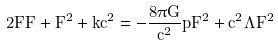Convert formula to latex. <formula><loc_0><loc_0><loc_500><loc_500>2 F \ddot { F } + { \dot { F } } ^ { 2 } + k c ^ { 2 } = - \frac { 8 \pi G } { c ^ { 2 } } p F ^ { 2 } + c ^ { 2 } \Lambda F ^ { 2 }</formula> 